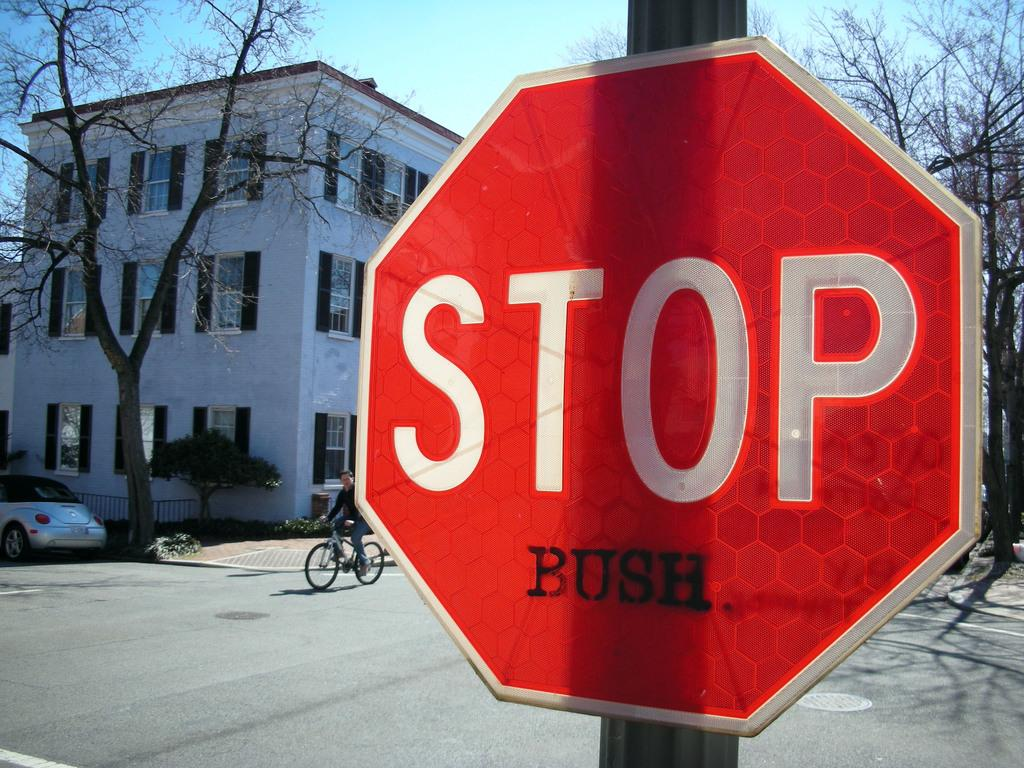<image>
Summarize the visual content of the image. A red stop sign with Bush added below it stands in a street. 